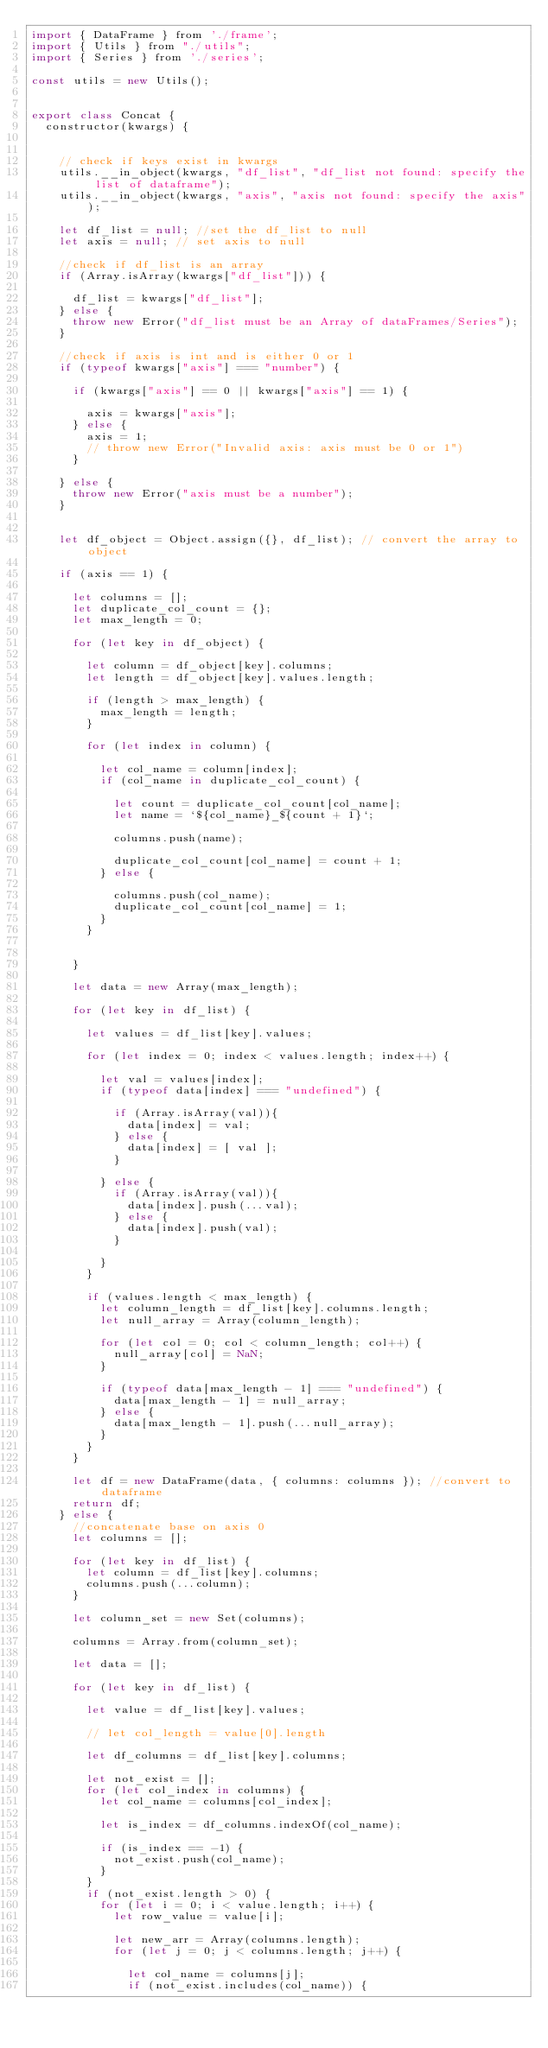<code> <loc_0><loc_0><loc_500><loc_500><_JavaScript_>import { DataFrame } from './frame';
import { Utils } from "./utils";
import { Series } from './series';

const utils = new Utils();


export class Concat {
  constructor(kwargs) {


    // check if keys exist in kwargs
    utils.__in_object(kwargs, "df_list", "df_list not found: specify the list of dataframe");
    utils.__in_object(kwargs, "axis", "axis not found: specify the axis");

    let df_list = null; //set the df_list to null
    let axis = null; // set axis to null

    //check if df_list is an array
    if (Array.isArray(kwargs["df_list"])) {

      df_list = kwargs["df_list"];
    } else {
      throw new Error("df_list must be an Array of dataFrames/Series");
    }

    //check if axis is int and is either 0 or 1
    if (typeof kwargs["axis"] === "number") {

      if (kwargs["axis"] == 0 || kwargs["axis"] == 1) {

        axis = kwargs["axis"];
      } else {
        axis = 1;
        // throw new Error("Invalid axis: axis must be 0 or 1")
      }

    } else {
      throw new Error("axis must be a number");
    }


    let df_object = Object.assign({}, df_list); // convert the array to object

    if (axis == 1) {

      let columns = [];
      let duplicate_col_count = {};
      let max_length = 0;

      for (let key in df_object) {

        let column = df_object[key].columns;
        let length = df_object[key].values.length;

        if (length > max_length) {
          max_length = length;
        }

        for (let index in column) {

          let col_name = column[index];
          if (col_name in duplicate_col_count) {

            let count = duplicate_col_count[col_name];
            let name = `${col_name}_${count + 1}`;

            columns.push(name);

            duplicate_col_count[col_name] = count + 1;
          } else {

            columns.push(col_name);
            duplicate_col_count[col_name] = 1;
          }
        }


      }

      let data = new Array(max_length);

      for (let key in df_list) {

        let values = df_list[key].values;

        for (let index = 0; index < values.length; index++) {

          let val = values[index];
          if (typeof data[index] === "undefined") {

            if (Array.isArray(val)){
              data[index] = val;
            } else {
              data[index] = [ val ];
            }

          } else {
            if (Array.isArray(val)){
              data[index].push(...val);
            } else {
              data[index].push(val);
            }

          }
        }

        if (values.length < max_length) {
          let column_length = df_list[key].columns.length;
          let null_array = Array(column_length);

          for (let col = 0; col < column_length; col++) {
            null_array[col] = NaN;
          }

          if (typeof data[max_length - 1] === "undefined") {
            data[max_length - 1] = null_array;
          } else {
            data[max_length - 1].push(...null_array);
          }
        }
      }

      let df = new DataFrame(data, { columns: columns }); //convert to dataframe
      return df;
    } else {
      //concatenate base on axis 0
      let columns = [];

      for (let key in df_list) {
        let column = df_list[key].columns;
        columns.push(...column);
      }

      let column_set = new Set(columns);

      columns = Array.from(column_set);

      let data = [];

      for (let key in df_list) {

        let value = df_list[key].values;

        // let col_length = value[0].length

        let df_columns = df_list[key].columns;

        let not_exist = [];
        for (let col_index in columns) {
          let col_name = columns[col_index];

          let is_index = df_columns.indexOf(col_name);

          if (is_index == -1) {
            not_exist.push(col_name);
          }
        }
        if (not_exist.length > 0) {
          for (let i = 0; i < value.length; i++) {
            let row_value = value[i];

            let new_arr = Array(columns.length);
            for (let j = 0; j < columns.length; j++) {

              let col_name = columns[j];
              if (not_exist.includes(col_name)) {
</code> 